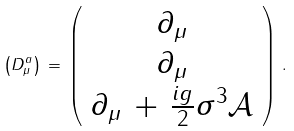Convert formula to latex. <formula><loc_0><loc_0><loc_500><loc_500>\left ( D _ { \mu } ^ { a } \right ) \, = \, \left ( \begin{array} { c } { { \partial _ { \mu } } } \\ { { \partial _ { \mu } } } \\ { { \partial _ { \mu } \, + \, \frac { i g } { 2 } \sigma ^ { 3 } \mathcal { A } } } \end{array} \right ) \, .</formula> 